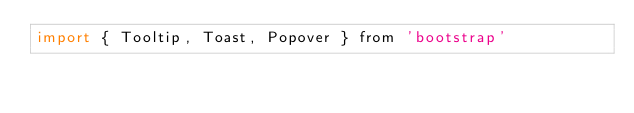Convert code to text. <code><loc_0><loc_0><loc_500><loc_500><_JavaScript_>import { Tooltip, Toast, Popover } from 'bootstrap'</code> 